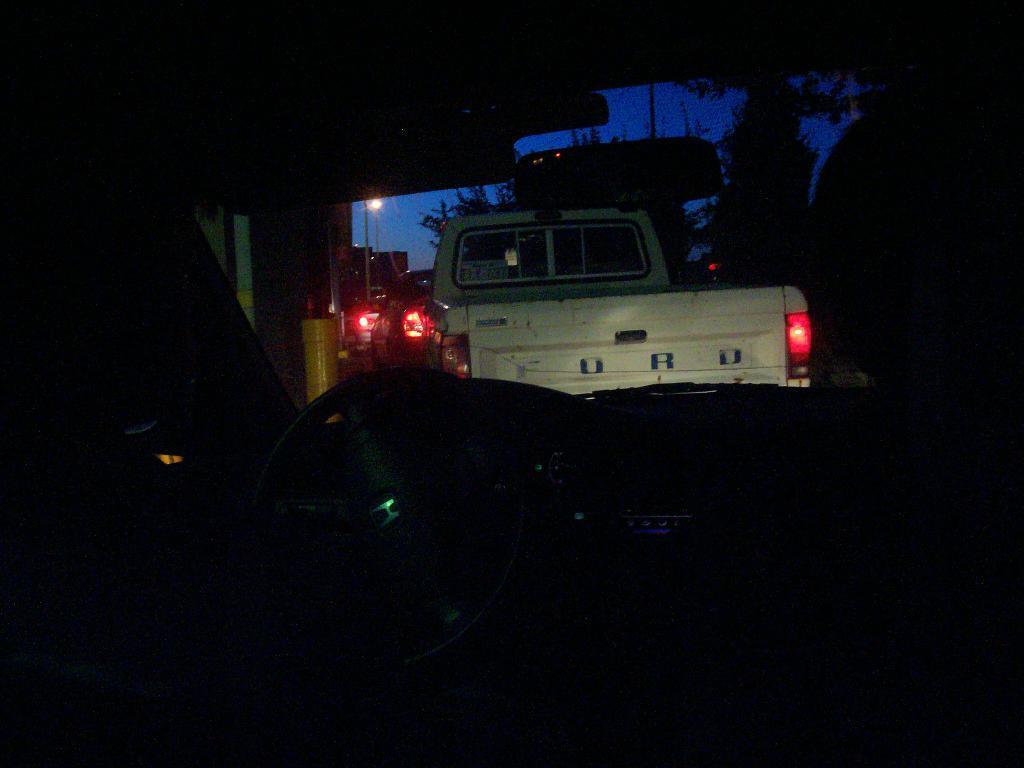Describe this image in one or two sentences. In the picture I can see groups of cars. In the middle of the image I can see red lights. There is a sky on the top of this image. 